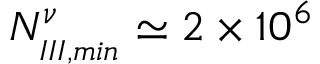<formula> <loc_0><loc_0><loc_500><loc_500>N _ { _ { I I I , \min } } ^ { \nu } \simeq 2 \times 1 0 ^ { 6 }</formula> 